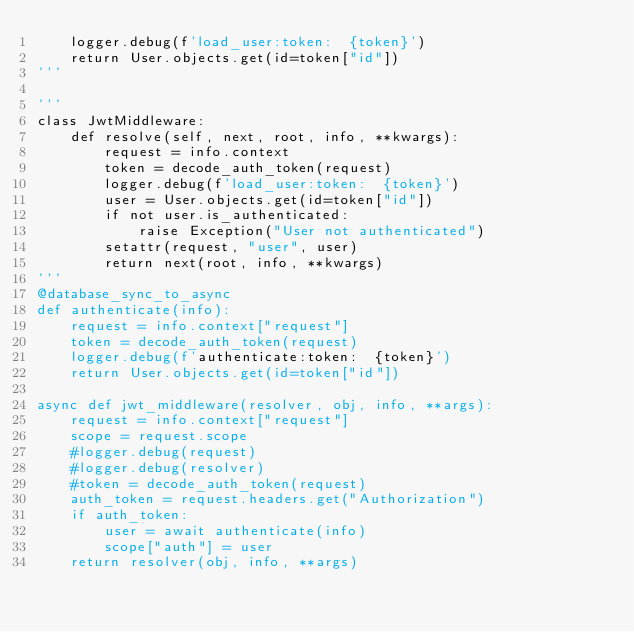<code> <loc_0><loc_0><loc_500><loc_500><_Python_>    logger.debug(f'load_user:token:  {token}')
    return User.objects.get(id=token["id"])
'''

'''
class JwtMiddleware:
    def resolve(self, next, root, info, **kwargs):
        request = info.context
        token = decode_auth_token(request)
        logger.debug(f'load_user:token:  {token}')
        user = User.objects.get(id=token["id"])
        if not user.is_authenticated:
            raise Exception("User not authenticated")
        setattr(request, "user", user)
        return next(root, info, **kwargs)
'''
@database_sync_to_async
def authenticate(info):
    request = info.context["request"]
    token = decode_auth_token(request)
    logger.debug(f'authenticate:token:  {token}')
    return User.objects.get(id=token["id"])

async def jwt_middleware(resolver, obj, info, **args):
    request = info.context["request"]
    scope = request.scope
    #logger.debug(request)
    #logger.debug(resolver)
    #token = decode_auth_token(request)
    auth_token = request.headers.get("Authorization")
    if auth_token:
        user = await authenticate(info)
        scope["auth"] = user
    return resolver(obj, info, **args)
</code> 